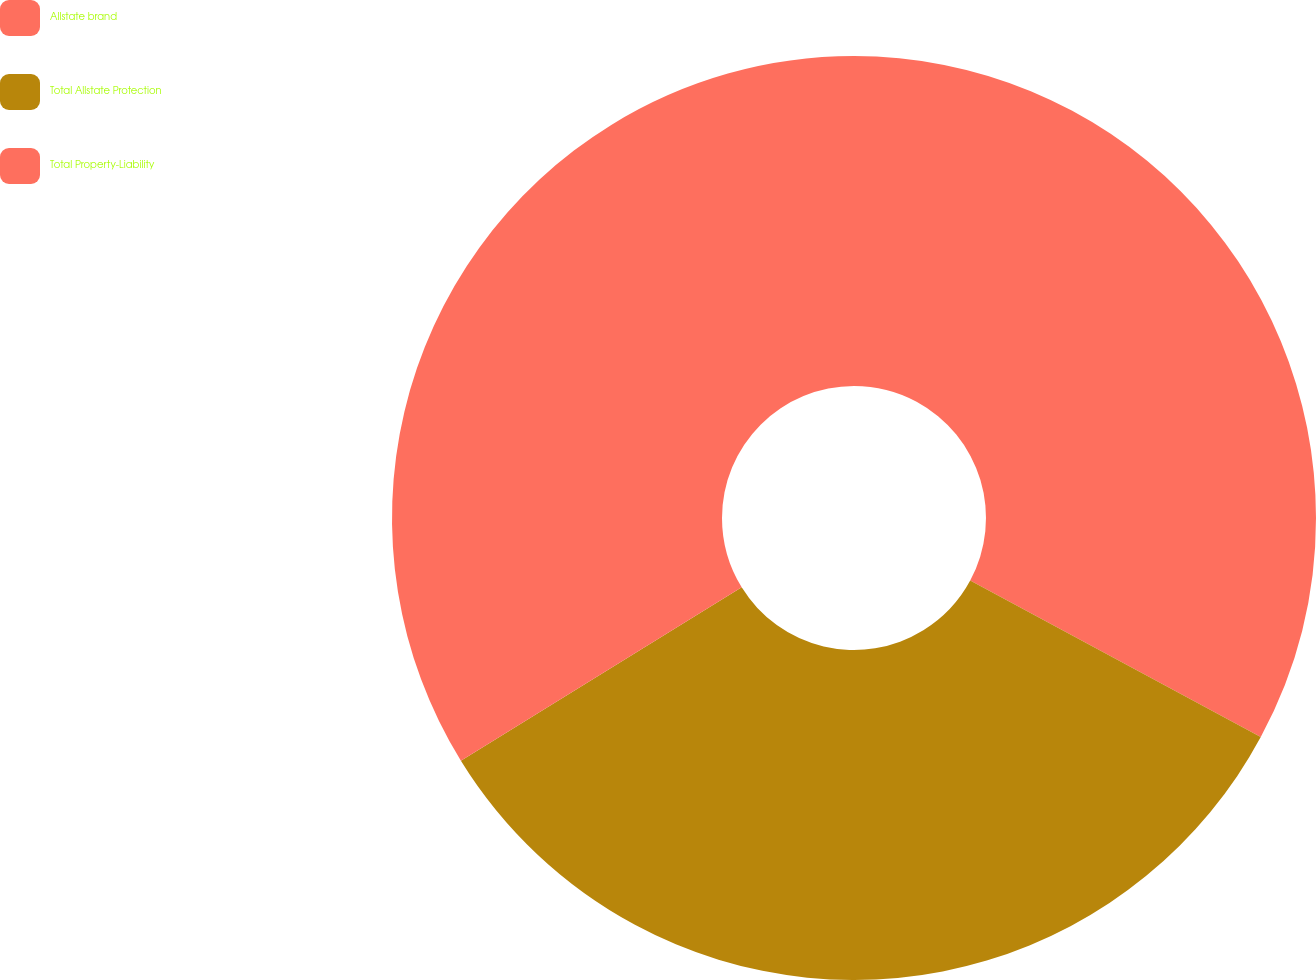<chart> <loc_0><loc_0><loc_500><loc_500><pie_chart><fcel>Allstate brand<fcel>Total Allstate Protection<fcel>Total Property-Liability<nl><fcel>32.86%<fcel>33.33%<fcel>33.8%<nl></chart> 